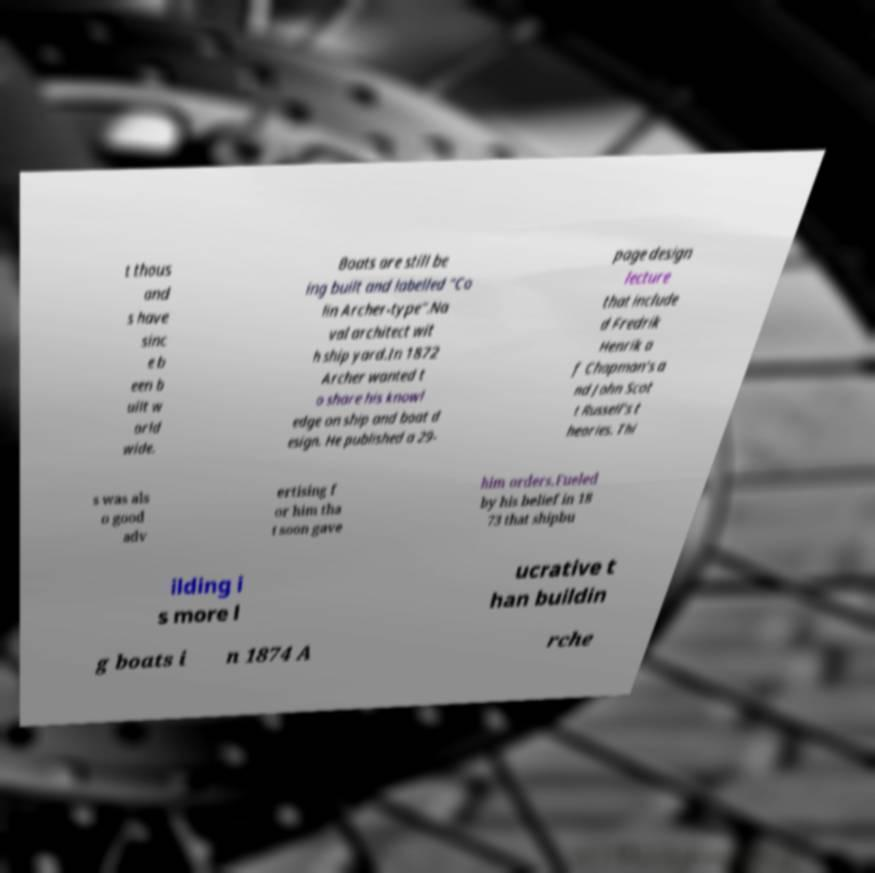Please identify and transcribe the text found in this image. t thous and s have sinc e b een b uilt w orld wide. Boats are still be ing built and labelled "Co lin Archer-type".Na val architect wit h ship yard.In 1872 Archer wanted t o share his knowl edge on ship and boat d esign. He published a 29- page design lecture that include d Fredrik Henrik a f Chapman's a nd John Scot t Russell's t heories. Thi s was als o good adv ertising f or him tha t soon gave him orders.Fueled by his belief in 18 73 that shipbu ilding i s more l ucrative t han buildin g boats i n 1874 A rche 